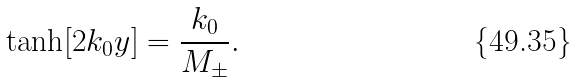<formula> <loc_0><loc_0><loc_500><loc_500>\tanh [ 2 k _ { 0 } y ] = \frac { k _ { 0 } } { M _ { \pm } } .</formula> 